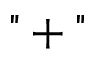<formula> <loc_0><loc_0><loc_500><loc_500>" + "</formula> 